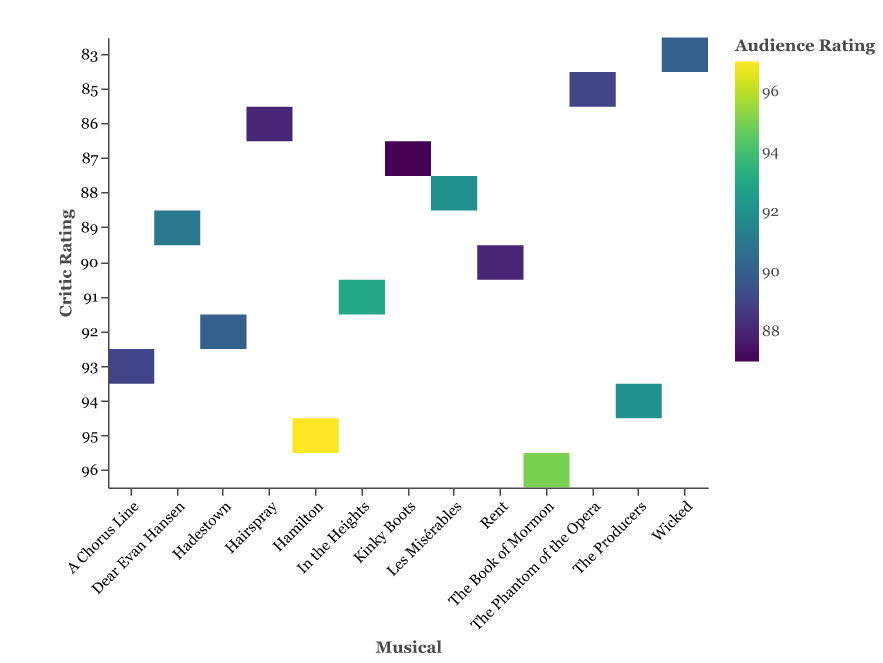What is the title of the heatmap? Look at the top of the heatmap where the title is displayed.
Answer: Critic vs Audience Ratings for Tony Award Winning Musicals Which musical has the highest Critic Rating? Look at the y-axis labeled "Critic Rating" and observe the musical with the highest rating, which is 96.
Answer: The Book of Mormon What color represents the highest Audience Rating? Look at the color scale on the right and identify the color corresponding to the highest Audience Rating, which is 97.
Answer: The highest Audience Rating is represented by a color on the viridis scale corresponding to 97 (which can be a light yellow) Which musical has the same Critic and Audience Rating? Check the plot for musicals with matching values on both the y-axis (Critic Rating) and the color indicating Audience Rating.
Answer: Kinky Boots What's the difference in Audience Rating between "Hamilton" and "Dear Evan Hansen"? Find the Audience Ratings for "Hamilton" (97) and "Dear Evan Hansen" (91). Subtract the lower rating from the higher one (97 - 91).
Answer: 6 Which musicals have a higher Critic Rating than "Wicked"? Locate "Wicked" on the y-axis and identify other musicals with Critic Ratings higher than Wicked's 83.
Answer: Hamilton, Dear Evan Hansen, The Book of Mormon, Hadestown, Rent, Les Misérables, A Chorus Line, In the Heights, The Producers What is the average Audience Rating of musicals with a Critic Rating of 90 or above? Identify musicals meeting the Critic Rating criterion: Hamilton, Dear Evan Hansen, The Book of Mormon, Hadestown, Rent, A Chorus Line, In the Heights, The Producers. Sum their Audience Ratings (97 + 91 + 95 + 90 + 88 + 89 + 93 + 92 = 735) and divide by the number of musicals (8).
Answer: 91.875 Which musicals have an Audience Rating that is more than 2 points higher than their Critic Rating? Compare the Critic and Audience Ratings for each musical: Hamilton (97-95), Dear Evan Hansen (91-89), Les Misérables (92-88), In the Heights (93-91), and Wicked (90-83) meet the criterion.
Answer: Hamilton, Dear Evan Hansen, Les Misérables, In the Heights, Wicked Which musical features the biggest discrepancy between Critic and Audience Ratings? Calculate the absolute differences between Critic and Audience Ratings for all musicals and identify the largest difference.
Answer: Wicked (difference of 7) What is the median Critic Rating of all the musicals? List all Critic Ratings in ascending order: 83, 85, 86, 87, 88, 88, 89, 90, 91, 92, 93, 94, 95, 96. For an odd number of values, the median is the middle value: 90.
Answer: 90 